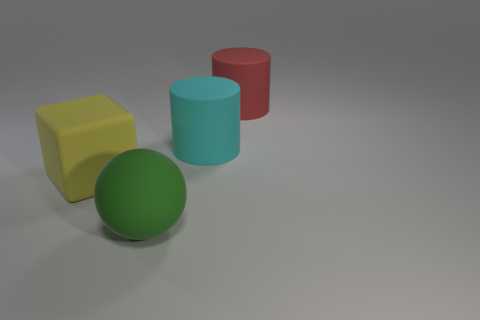What is the size of the thing that is both behind the large block and to the left of the big red object?
Offer a terse response. Large. How big is the rubber thing in front of the thing to the left of the big matte object in front of the yellow thing?
Your answer should be very brief. Large. What is the size of the red matte object?
Offer a very short reply. Large. Is there any other thing that has the same material as the cube?
Ensure brevity in your answer.  Yes. There is a big matte cylinder left of the large thing behind the cyan rubber cylinder; is there a red thing that is on the left side of it?
Offer a very short reply. No. How many tiny objects are either green rubber things or cyan shiny objects?
Offer a terse response. 0. Are there any other things of the same color as the block?
Offer a terse response. No. There is a object that is to the left of the green matte ball; is its size the same as the big green object?
Offer a very short reply. Yes. What color is the large rubber thing that is to the left of the thing that is in front of the big object left of the large green matte ball?
Make the answer very short. Yellow. The sphere has what color?
Your response must be concise. Green. 